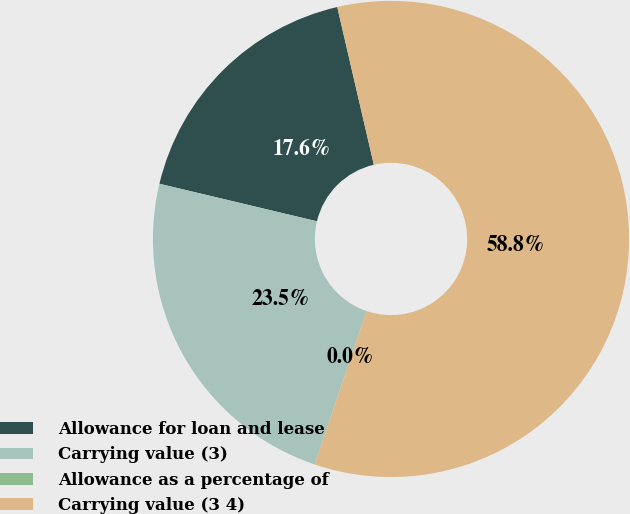Convert chart to OTSL. <chart><loc_0><loc_0><loc_500><loc_500><pie_chart><fcel>Allowance for loan and lease<fcel>Carrying value (3)<fcel>Allowance as a percentage of<fcel>Carrying value (3 4)<nl><fcel>17.65%<fcel>23.53%<fcel>0.0%<fcel>58.82%<nl></chart> 